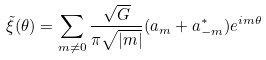<formula> <loc_0><loc_0><loc_500><loc_500>\tilde { \xi } ( \theta ) = \sum _ { m \neq 0 } \frac { \sqrt { G } } { \pi \sqrt { | m | } } ( a _ { m } + a ^ { * } _ { - m } ) e ^ { i m \theta }</formula> 